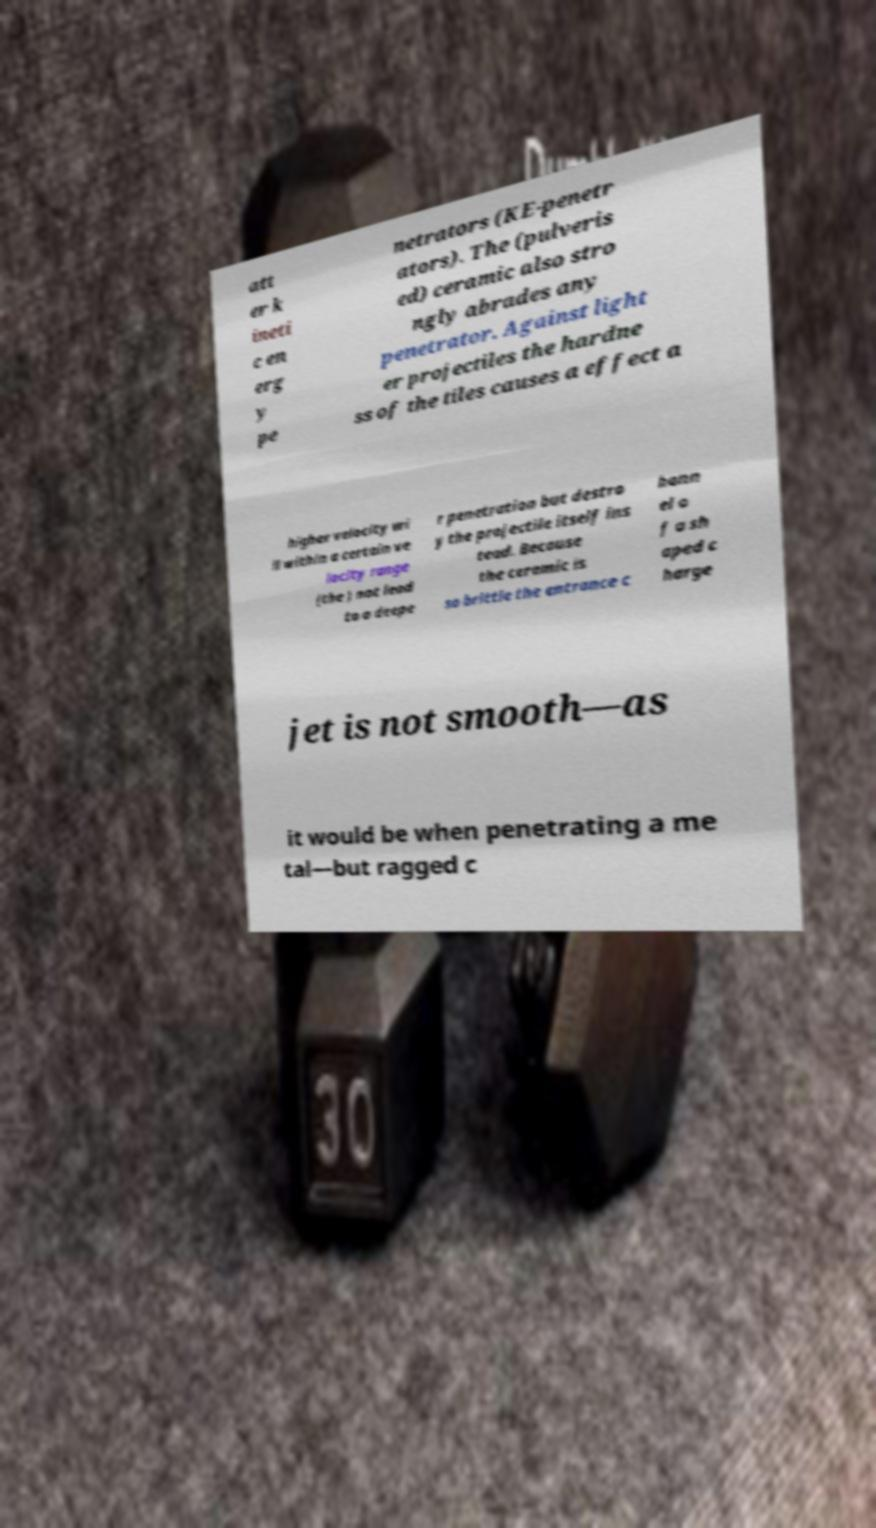Could you assist in decoding the text presented in this image and type it out clearly? att er k ineti c en erg y pe netrators (KE-penetr ators). The (pulveris ed) ceramic also stro ngly abrades any penetrator. Against light er projectiles the hardne ss of the tiles causes a effect a higher velocity wi ll within a certain ve locity range (the ) not lead to a deepe r penetration but destro y the projectile itself ins tead. Because the ceramic is so brittle the entrance c hann el o f a sh aped c harge jet is not smooth—as it would be when penetrating a me tal—but ragged c 